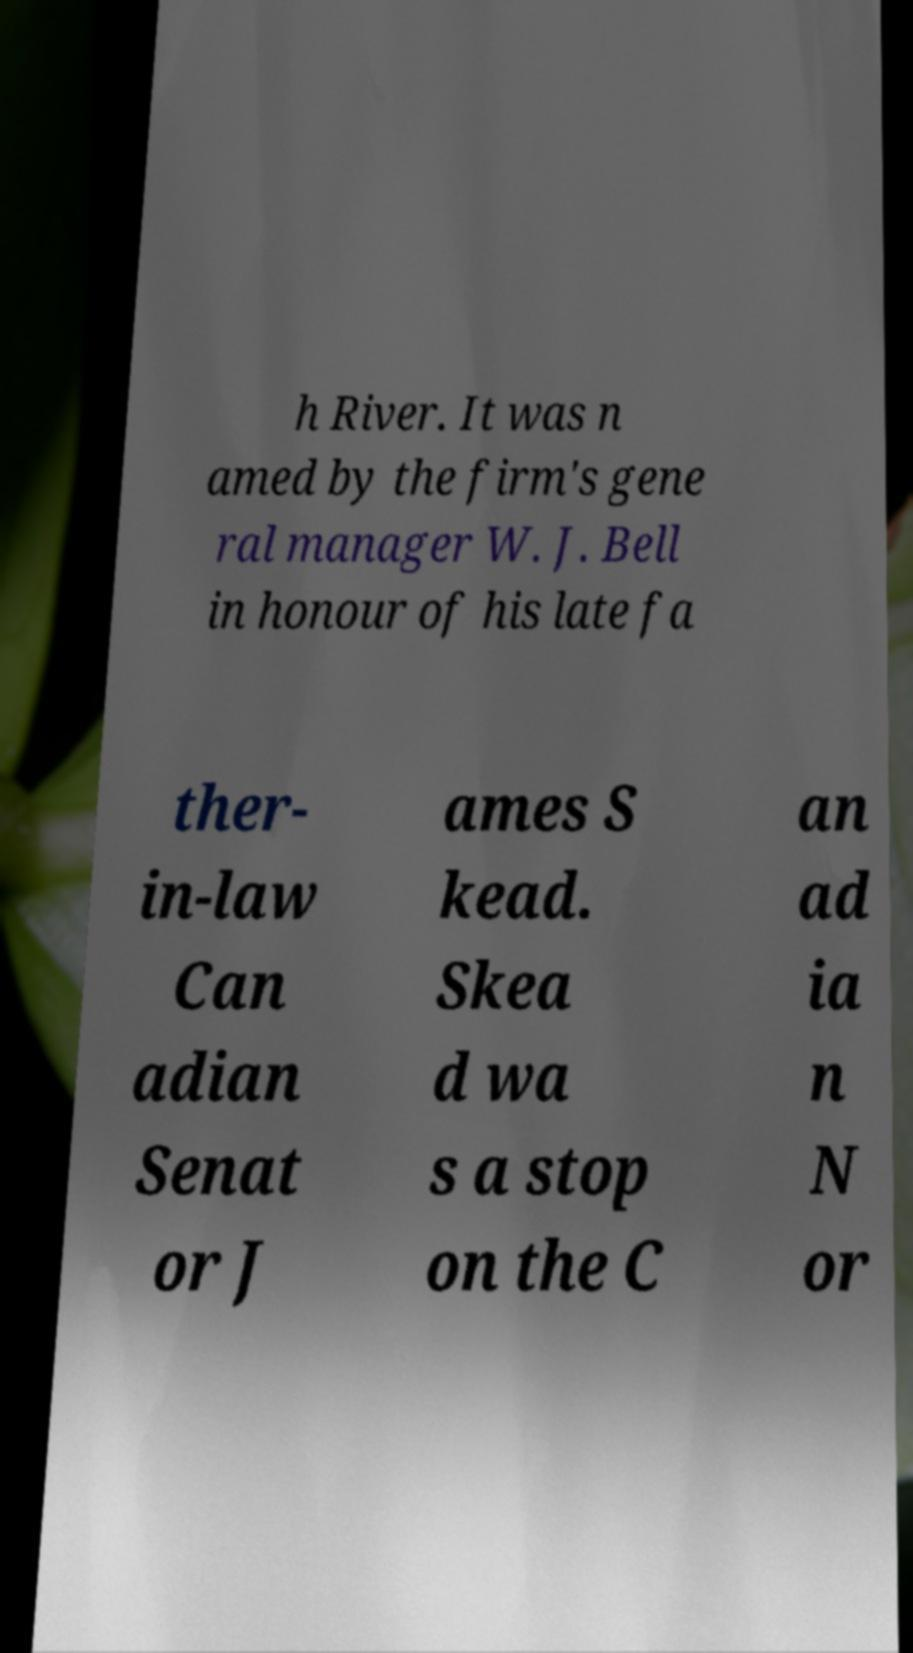Can you accurately transcribe the text from the provided image for me? h River. It was n amed by the firm's gene ral manager W. J. Bell in honour of his late fa ther- in-law Can adian Senat or J ames S kead. Skea d wa s a stop on the C an ad ia n N or 